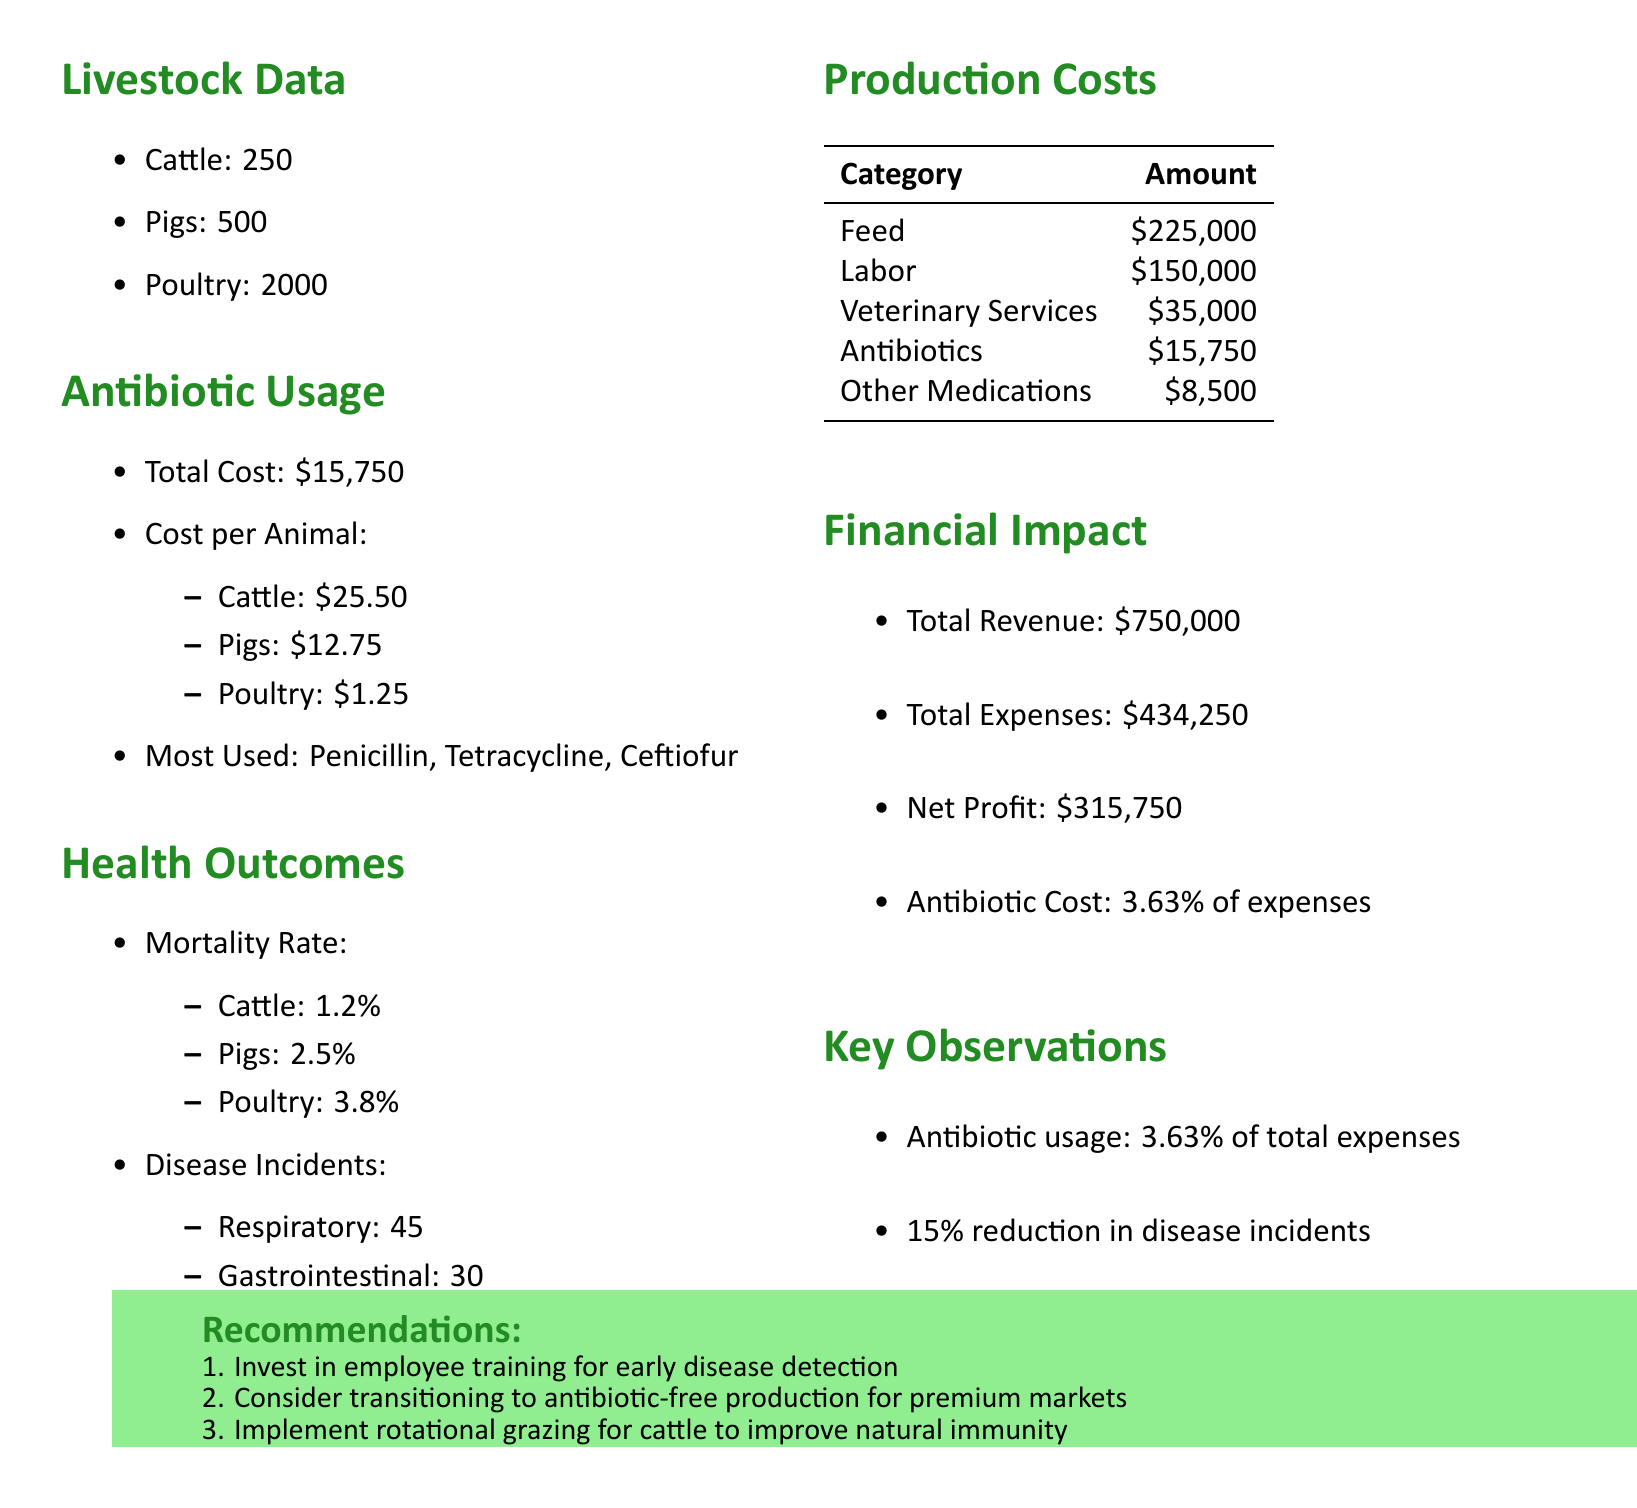What is the total cost of antibiotics used? The total cost of antibiotics is explicitly mentioned in the document under the antibiotic usage section.
Answer: $15,750 What is the mortality rate for pigs? The mortality rate for pigs is part of the health outcomes section, where specific rates for each livestock type are shown.
Answer: 2.5% How many cattle are present on the farm? The number of cattle is stated in the livestock data section for clarity on the farm's livestock count.
Answer: 250 What percentage of total expenses does antibiotic usage represent? The antibiotic cost percentage is calculated and included in the financial impact section of the report.
Answer: 3.63% What is the total revenue of the farm? The total revenue is clearly stated in the financial impact section as part of the overall financial summary.
Answer: $750,000 How many respiratory disease incidents were reported? The number of respiratory incidents is recorded in the health outcomes section, providing data on disease occurrences.
Answer: 45 What is one key observation from the report? Key observations are listed to summarize important findings from the antibiotic usage report.
Answer: Antibiotic usage represents 3.63% of total expenses What recommendation is made regarding employee training? Recommendations for improvements include specific actions that can enhance farm operations and are listed at the end of the document.
Answer: Invest in employee training for early disease detection 